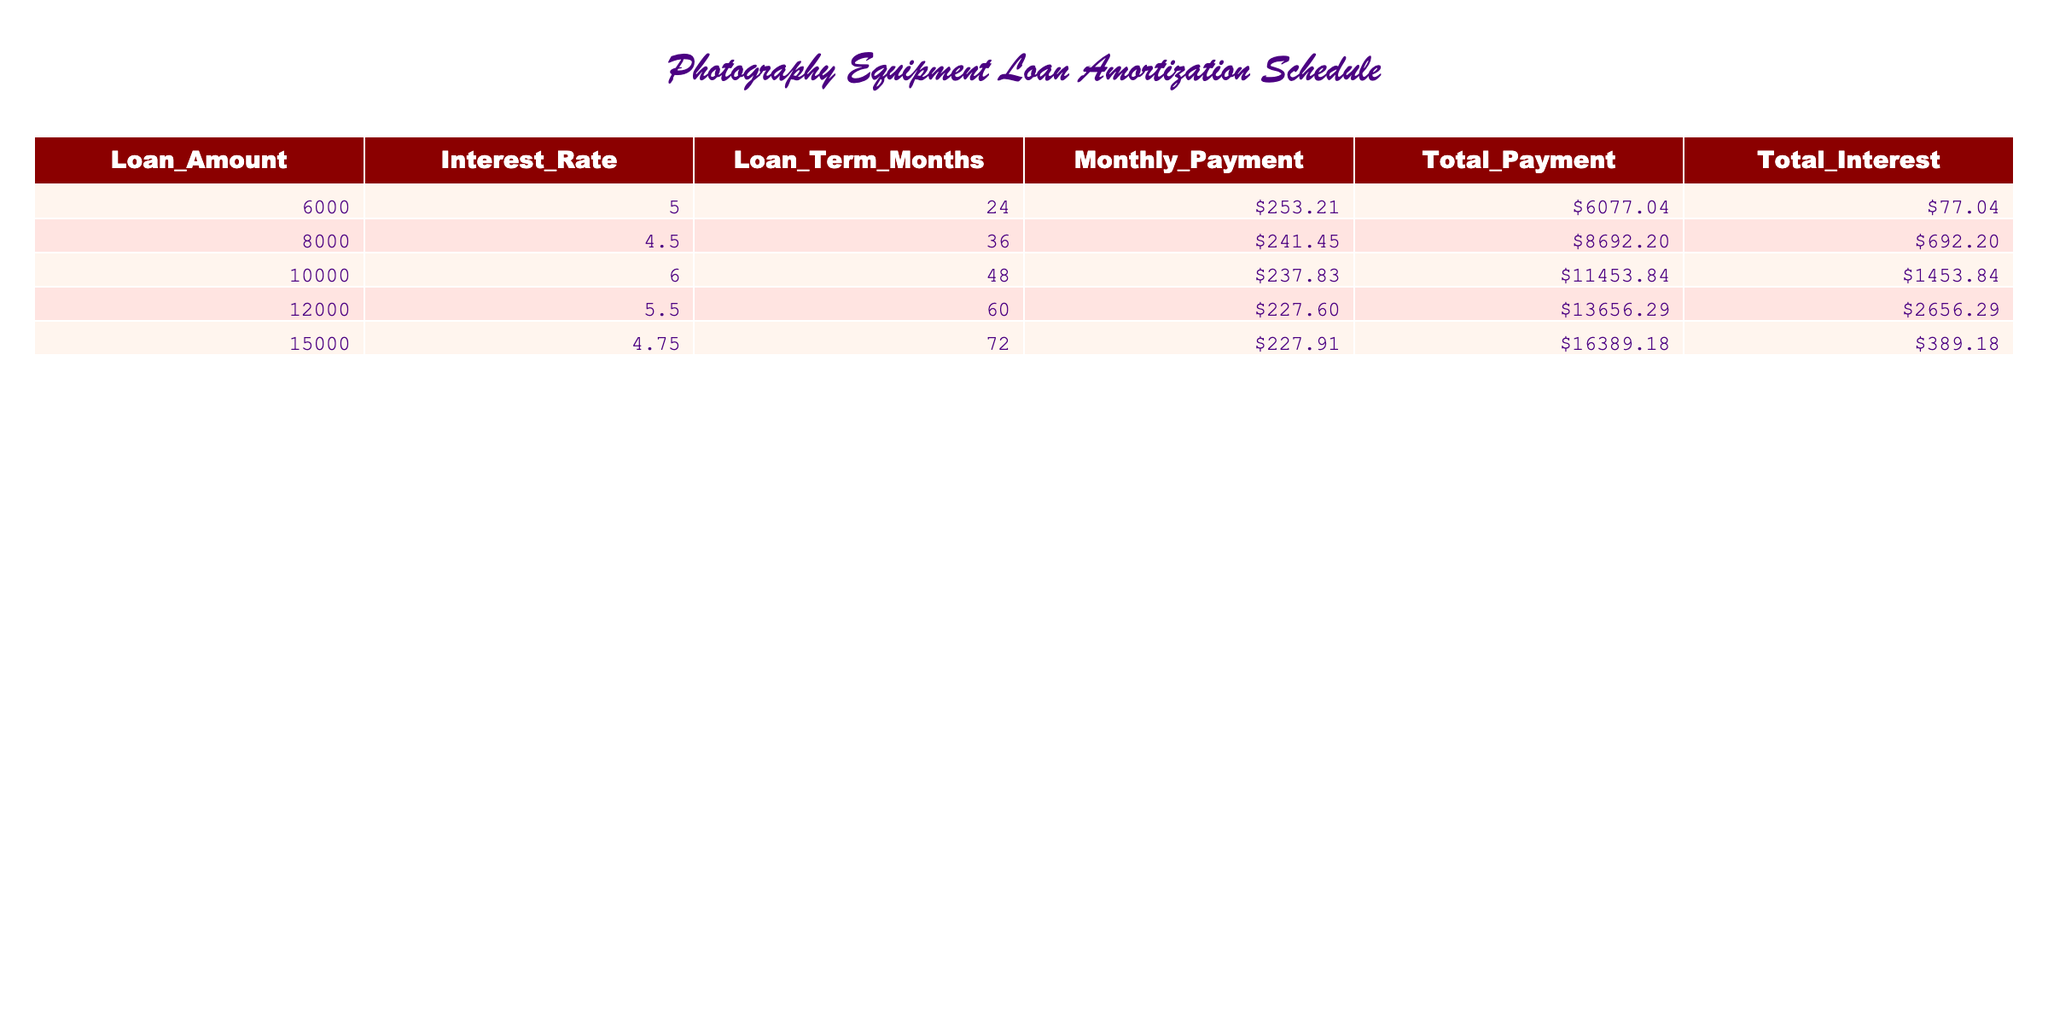What is the loan amount for the highest monthly payment? The highest monthly payment listed in the table is $253.21, which corresponds to a loan amount of $6000. Therefore, the answer is the loan amount related to that monthly payment.
Answer: 6000 What is the total payment for the loan with a term of 72 months? Looking at the table, the loan term of 72 months corresponds to a total payment of $16389.18.
Answer: 16389.18 Is the total interest for the $10000 loan more than the total interest for the $8000 loan? The total interest for the $10000 loan is $1453.84 and for the $8000 loan it is $692.20. Since $1453.84 is greater than $692.20, the statement is true.
Answer: Yes What is the difference in total payment between the $12000 loan and the $15000 loan? The total payment for the $12000 loan is $13656.29, and for the $15000 loan, it is $16389.18. To find the difference, we subtract: $16389.18 - $13656.29 = $2732.89.
Answer: 2732.89 What is the average interest rate across all loans listed in the table? Add the interest rates: 5 + 4.5 + 6 + 5.5 + 4.75 = 25.75. There are 5 loans, so divide the total by 5: 25.75 / 5 = 5.15.
Answer: 5.15 Which loan has the lowest total interest, and what is that interest amount? To find the lowest total interest, we check each loan’s total interest amounts: $77.04, $692.20, $1453.84, $2656.29, and $389.18. The lowest is $77.04, which corresponds to the $6000 loan.
Answer: 6000 and 77.04 Is the monthly payment for the $8000 loan higher than that for the $15000 loan? The monthly payment for the $8000 loan is $241.45, while for the $15000 loan, it’s $227.91. Since $241.45 is greater than $227.91, the statement is true.
Answer: Yes What is the percentage increase in total payment from the $6000 loan to the $12000 loan? Calculate total payments $13656.29 - $6077.04 = $7580.25. Then divide by the original total payment ($6077.04) and multiply by 100: ($7580.25 / $6077.04) * 100 ≈ 124.78%.
Answer: 124.78% What is the total amount paid in interest for the loan with the highest amount borrowed? The loan with the highest amount borrowed is $15000, with a total interest of $389.18.
Answer: 389.18 